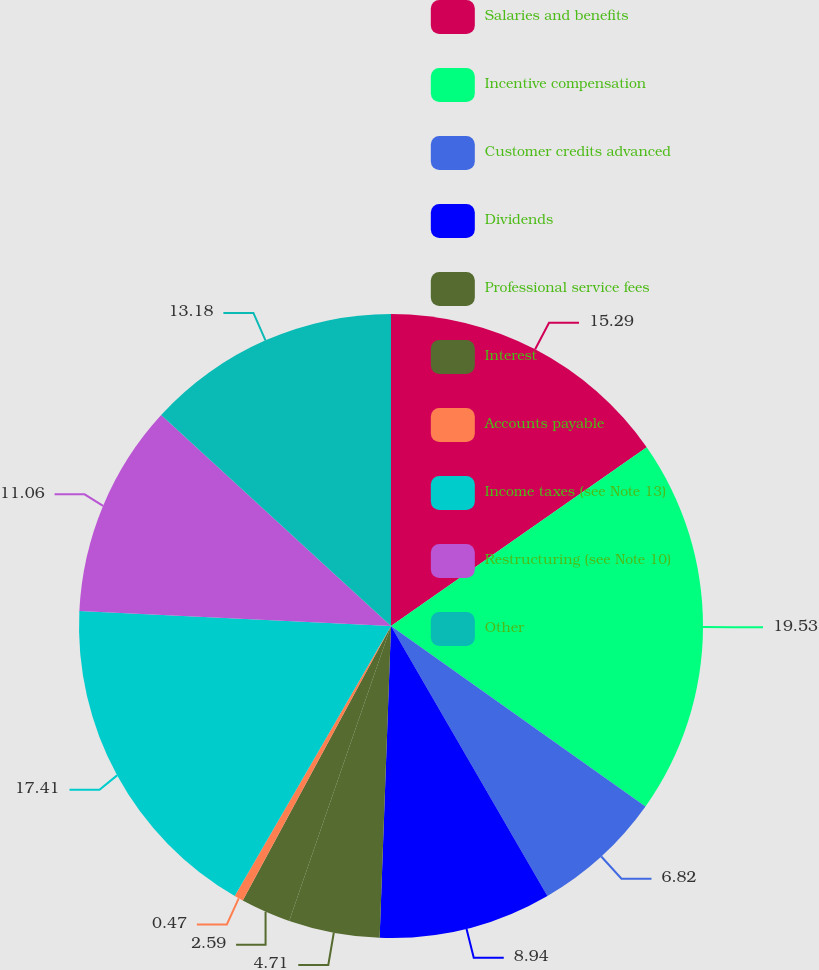Convert chart. <chart><loc_0><loc_0><loc_500><loc_500><pie_chart><fcel>Salaries and benefits<fcel>Incentive compensation<fcel>Customer credits advanced<fcel>Dividends<fcel>Professional service fees<fcel>Interest<fcel>Accounts payable<fcel>Income taxes (see Note 13)<fcel>Restructuring (see Note 10)<fcel>Other<nl><fcel>15.29%<fcel>19.53%<fcel>6.82%<fcel>8.94%<fcel>4.71%<fcel>2.59%<fcel>0.47%<fcel>17.41%<fcel>11.06%<fcel>13.18%<nl></chart> 